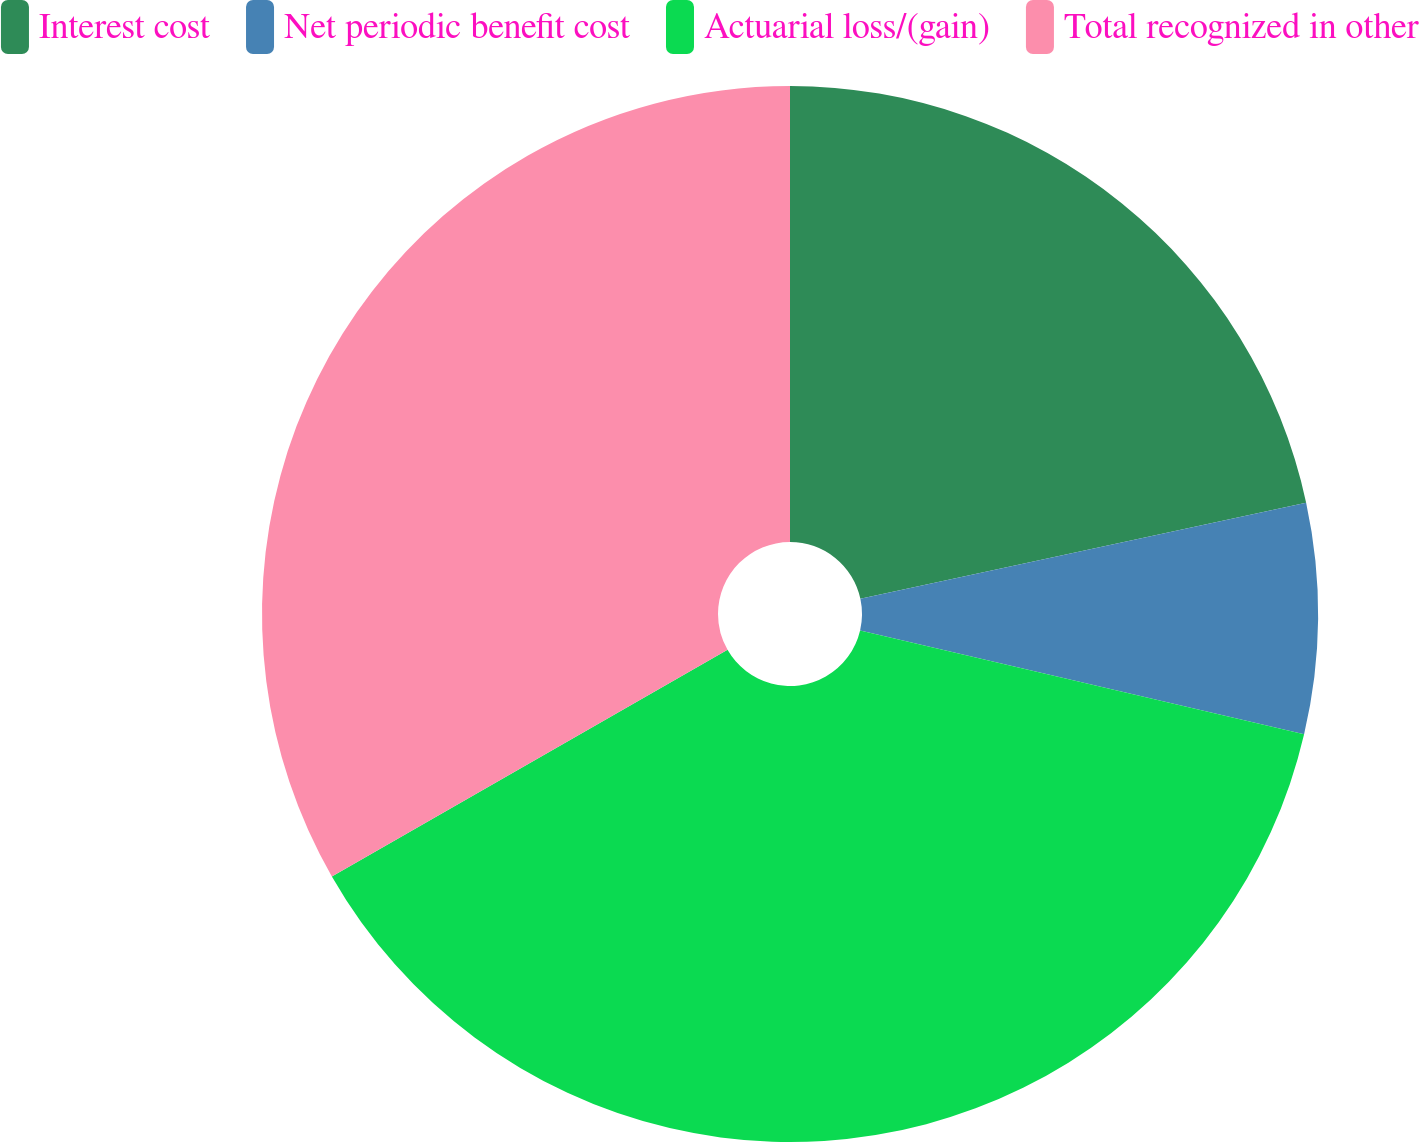<chart> <loc_0><loc_0><loc_500><loc_500><pie_chart><fcel>Interest cost<fcel>Net periodic benefit cost<fcel>Actuarial loss/(gain)<fcel>Total recognized in other<nl><fcel>21.62%<fcel>7.04%<fcel>38.06%<fcel>33.28%<nl></chart> 